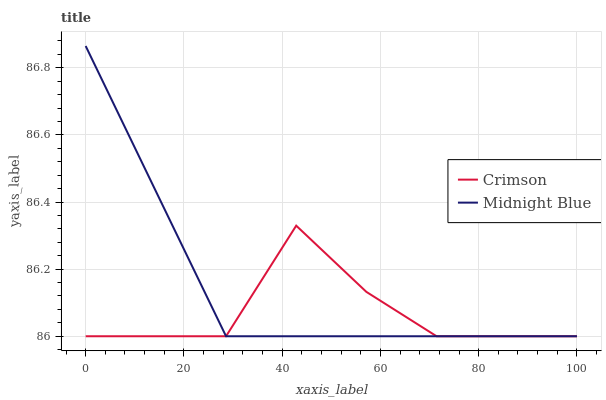Does Crimson have the minimum area under the curve?
Answer yes or no. Yes. Does Midnight Blue have the maximum area under the curve?
Answer yes or no. Yes. Does Midnight Blue have the minimum area under the curve?
Answer yes or no. No. Is Midnight Blue the smoothest?
Answer yes or no. Yes. Is Crimson the roughest?
Answer yes or no. Yes. Is Midnight Blue the roughest?
Answer yes or no. No. Does Crimson have the lowest value?
Answer yes or no. Yes. Does Midnight Blue have the highest value?
Answer yes or no. Yes. Does Crimson intersect Midnight Blue?
Answer yes or no. Yes. Is Crimson less than Midnight Blue?
Answer yes or no. No. Is Crimson greater than Midnight Blue?
Answer yes or no. No. 